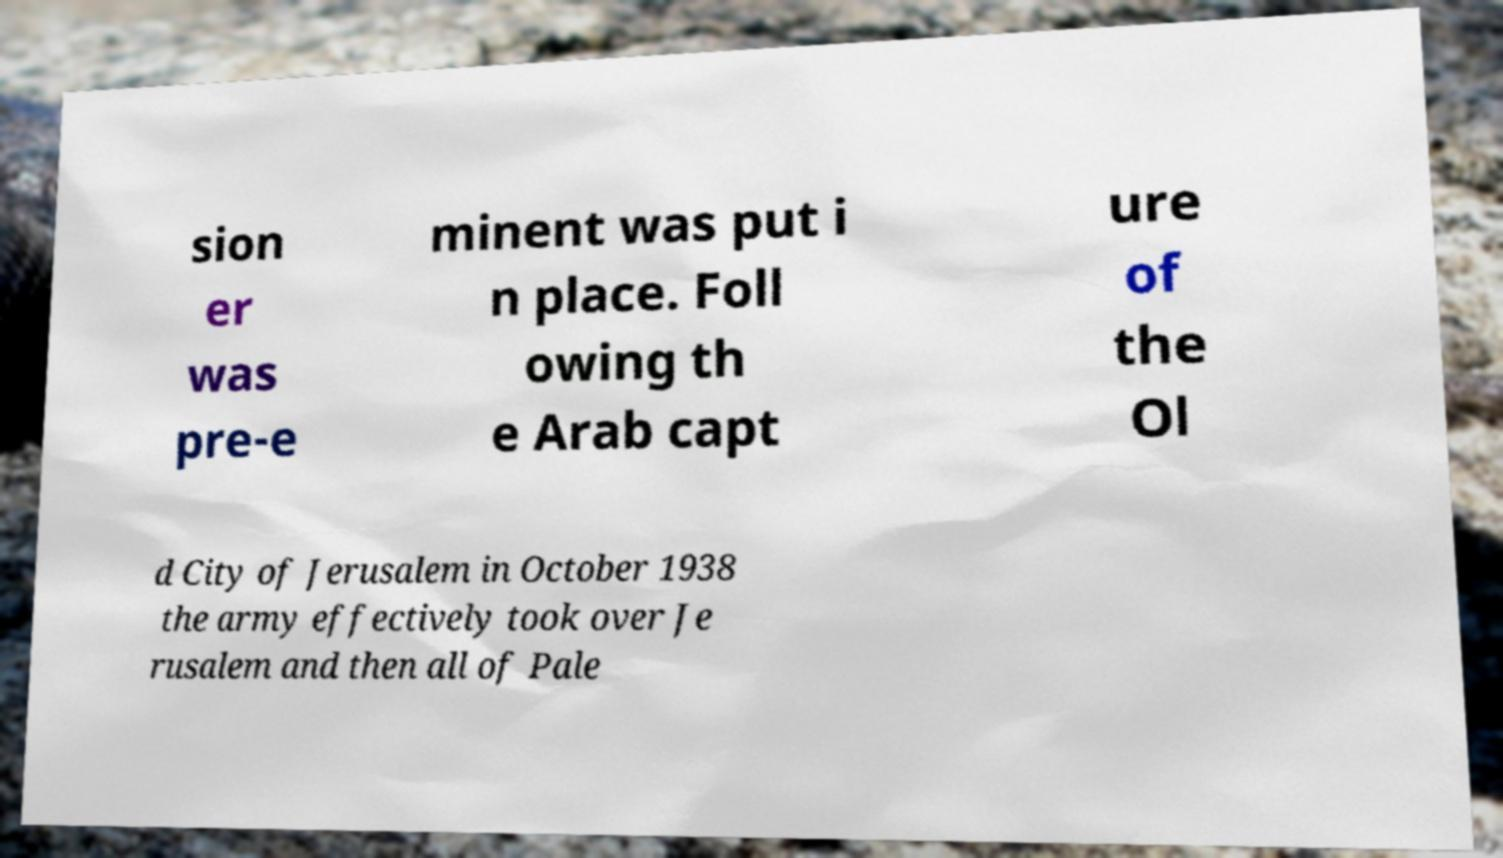For documentation purposes, I need the text within this image transcribed. Could you provide that? sion er was pre-e minent was put i n place. Foll owing th e Arab capt ure of the Ol d City of Jerusalem in October 1938 the army effectively took over Je rusalem and then all of Pale 